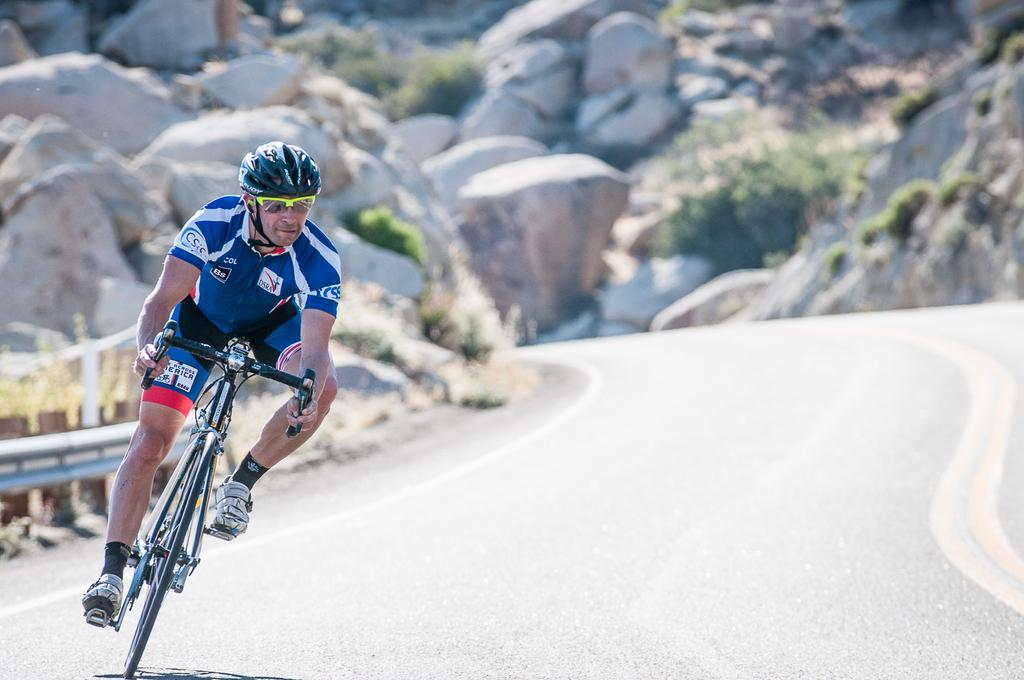Who or what is in the image? There is a person in the image. What is the person doing in the image? The person is sitting on a bicycle. What safety gear is the person wearing? The person is wearing a helmet. What type of eyewear is the person wearing? The person is wearing sunglasses. What type of terrain can be seen in the image? There are rocks and hills visible in the image. What type of mouth can be seen on the volcano in the image? There is no volcano present in the image, so there is no mouth to observe. 